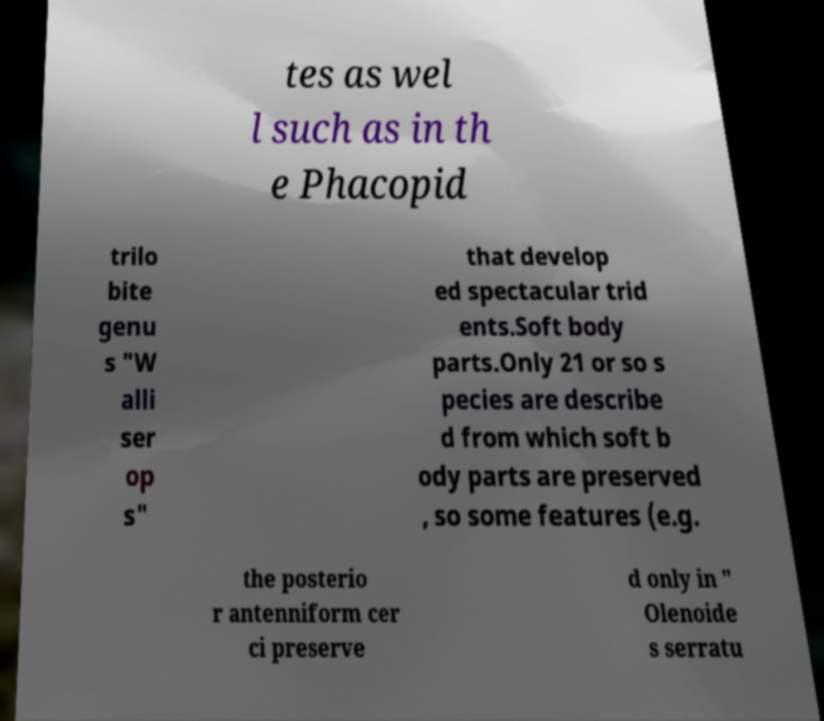Could you assist in decoding the text presented in this image and type it out clearly? tes as wel l such as in th e Phacopid trilo bite genu s "W alli ser op s" that develop ed spectacular trid ents.Soft body parts.Only 21 or so s pecies are describe d from which soft b ody parts are preserved , so some features (e.g. the posterio r antenniform cer ci preserve d only in " Olenoide s serratu 